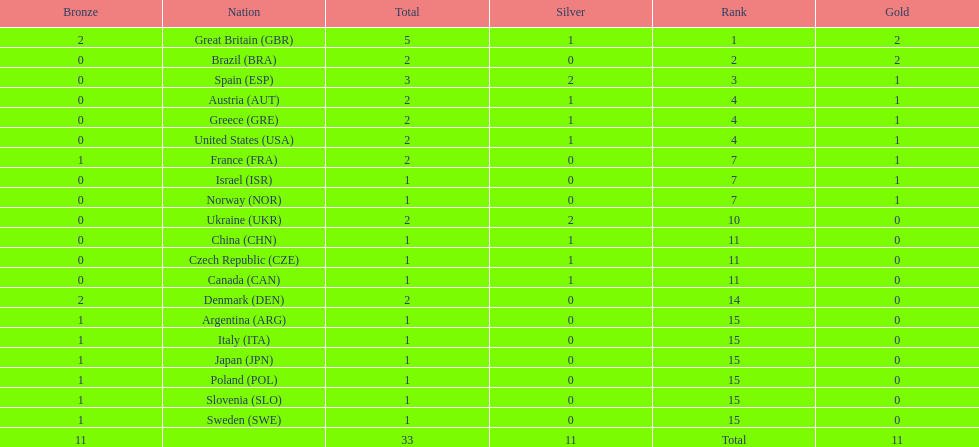Would you mind parsing the complete table? {'header': ['Bronze', 'Nation', 'Total', 'Silver', 'Rank', 'Gold'], 'rows': [['2', 'Great Britain\xa0(GBR)', '5', '1', '1', '2'], ['0', 'Brazil\xa0(BRA)', '2', '0', '2', '2'], ['0', 'Spain\xa0(ESP)', '3', '2', '3', '1'], ['0', 'Austria\xa0(AUT)', '2', '1', '4', '1'], ['0', 'Greece\xa0(GRE)', '2', '1', '4', '1'], ['0', 'United States\xa0(USA)', '2', '1', '4', '1'], ['1', 'France\xa0(FRA)', '2', '0', '7', '1'], ['0', 'Israel\xa0(ISR)', '1', '0', '7', '1'], ['0', 'Norway\xa0(NOR)', '1', '0', '7', '1'], ['0', 'Ukraine\xa0(UKR)', '2', '2', '10', '0'], ['0', 'China\xa0(CHN)', '1', '1', '11', '0'], ['0', 'Czech Republic\xa0(CZE)', '1', '1', '11', '0'], ['0', 'Canada\xa0(CAN)', '1', '1', '11', '0'], ['2', 'Denmark\xa0(DEN)', '2', '0', '14', '0'], ['1', 'Argentina\xa0(ARG)', '1', '0', '15', '0'], ['1', 'Italy\xa0(ITA)', '1', '0', '15', '0'], ['1', 'Japan\xa0(JPN)', '1', '0', '15', '0'], ['1', 'Poland\xa0(POL)', '1', '0', '15', '0'], ['1', 'Slovenia\xa0(SLO)', '1', '0', '15', '0'], ['1', 'Sweden\xa0(SWE)', '1', '0', '15', '0'], ['11', '', '33', '11', 'Total', '11']]} How many gold medals did italy receive? 0. 